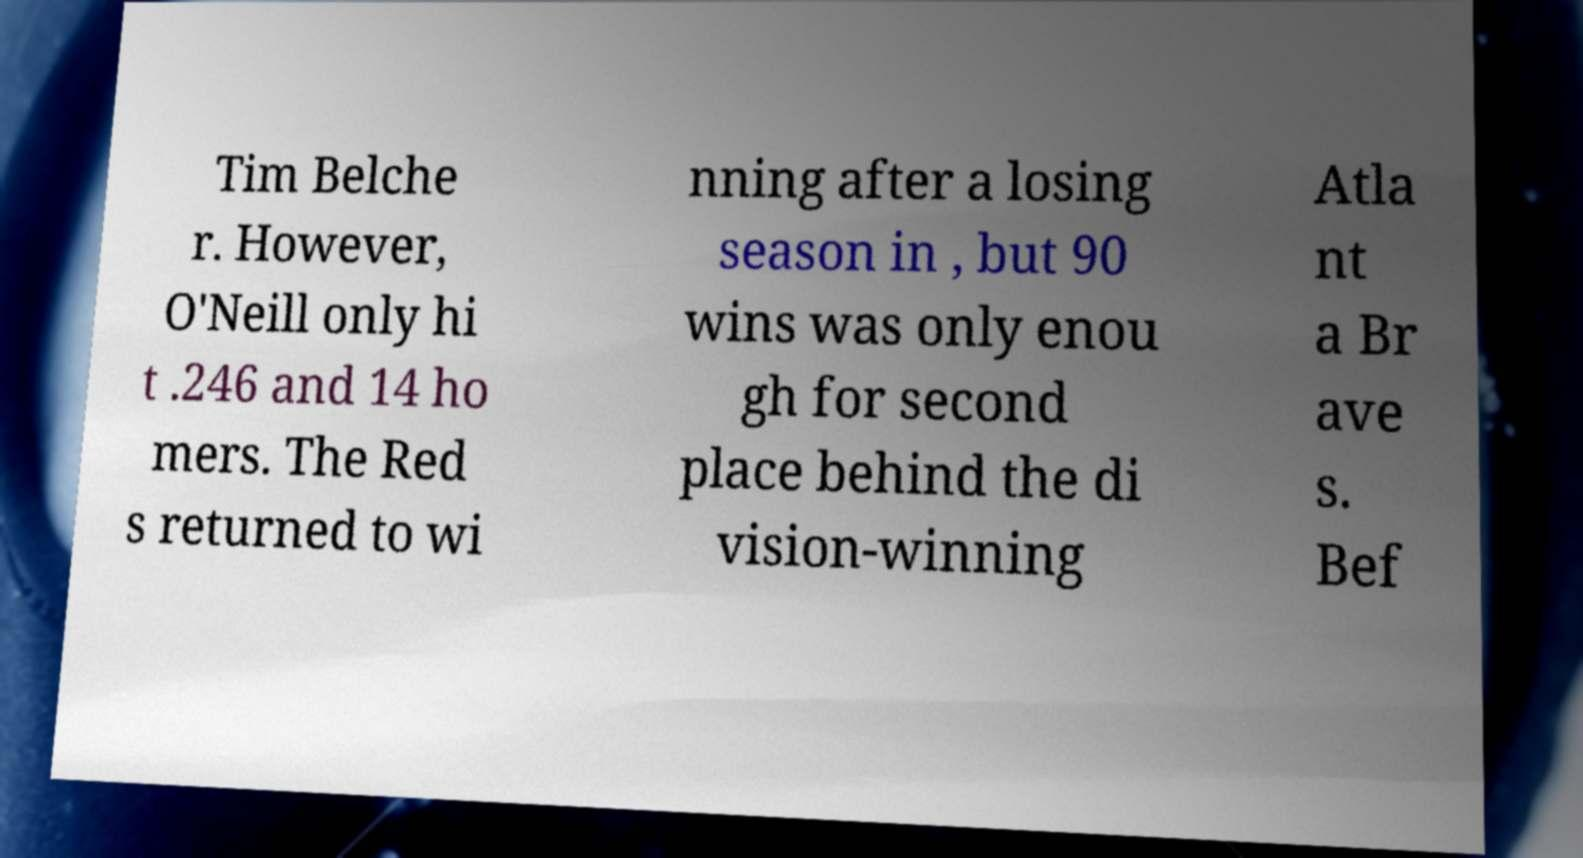Please read and relay the text visible in this image. What does it say? Tim Belche r. However, O'Neill only hi t .246 and 14 ho mers. The Red s returned to wi nning after a losing season in , but 90 wins was only enou gh for second place behind the di vision-winning Atla nt a Br ave s. Bef 